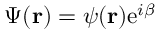Convert formula to latex. <formula><loc_0><loc_0><loc_500><loc_500>\Psi ( { r } ) = \psi ( { r } ) e ^ { i \beta }</formula> 